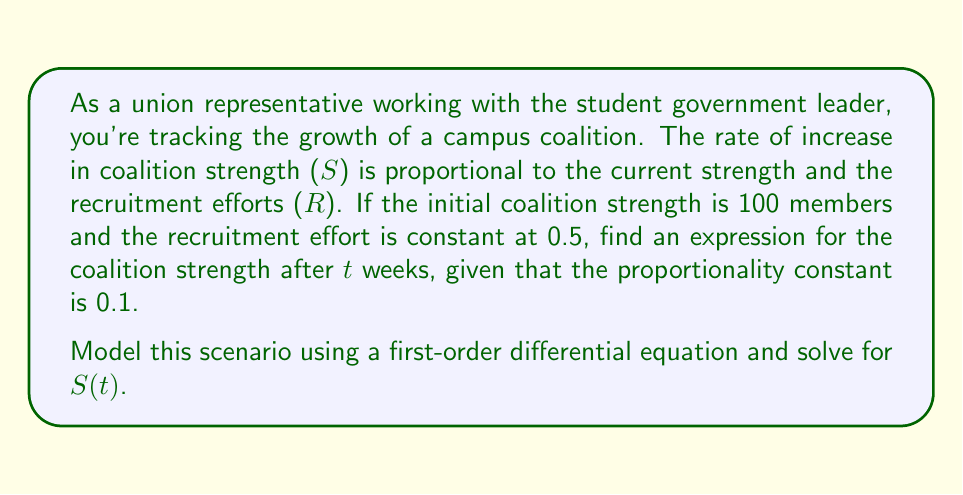Can you solve this math problem? Let's approach this step-by-step:

1) We can model this scenario with the following differential equation:

   $$\frac{dS}{dt} = kS + R$$

   where k is the proportionality constant, S is the coalition strength, and R is the recruitment effort.

2) We're given that k = 0.1 and R = 0.5. Substituting these values:

   $$\frac{dS}{dt} = 0.1S + 0.5$$

3) This is a linear first-order differential equation of the form:

   $$\frac{dy}{dx} + P(x)y = Q(x)$$

   where $P(x) = -0.1$ and $Q(x) = 0.5$

4) The general solution for this type of equation is:

   $$y = e^{-\int P(x)dx} (\int Q(x)e^{\int P(x)dx}dx + C)$$

5) In our case:

   $$S = e^{0.1t} (\int 0.5e^{-0.1t}dt + C)$$

6) Solving the integral:

   $$S = e^{0.1t} (-5e^{-0.1t} + C)$$

7) Simplifying:

   $$S = -5 + Ce^{0.1t}$$

8) Using the initial condition S(0) = 100:

   $$100 = -5 + C$$
   $$C = 105$$

9) Therefore, the final solution is:

   $$S(t) = -5 + 105e^{0.1t}$$

This expression gives the coalition strength after t weeks.
Answer: $S(t) = -5 + 105e^{0.1t}$ 